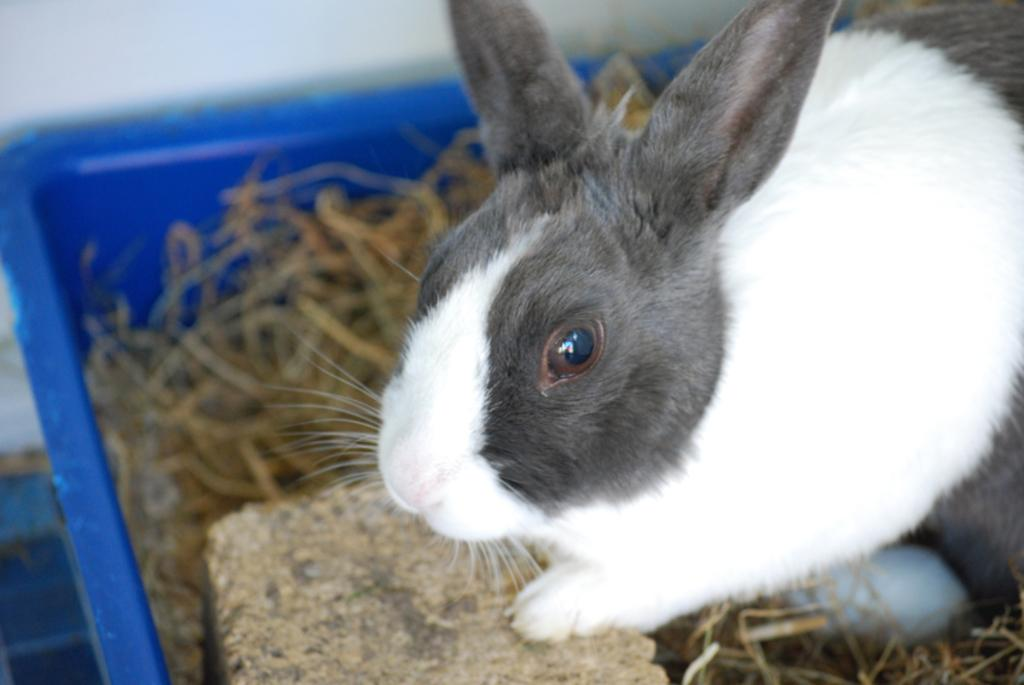What animal is present in the image? There is a rabbit in the image. Where is the rabbit located? The rabbit is sitting in a tub. What is inside the tub with the rabbit? The tub is filled with grass. What type of judge is sitting next to the rabbit in the image? There is no judge present in the image; it only features a rabbit sitting in a tub filled with grass. 